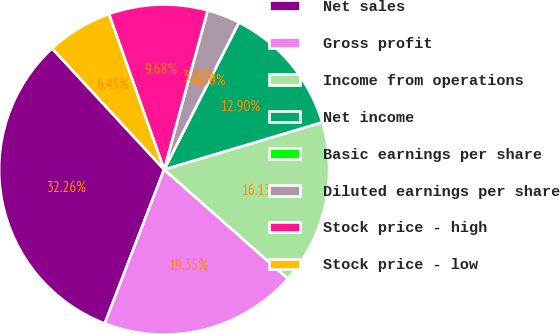Convert chart to OTSL. <chart><loc_0><loc_0><loc_500><loc_500><pie_chart><fcel>Net sales<fcel>Gross profit<fcel>Income from operations<fcel>Net income<fcel>Basic earnings per share<fcel>Diluted earnings per share<fcel>Stock price - high<fcel>Stock price - low<nl><fcel>32.26%<fcel>19.35%<fcel>16.13%<fcel>12.9%<fcel>0.0%<fcel>3.23%<fcel>9.68%<fcel>6.45%<nl></chart> 